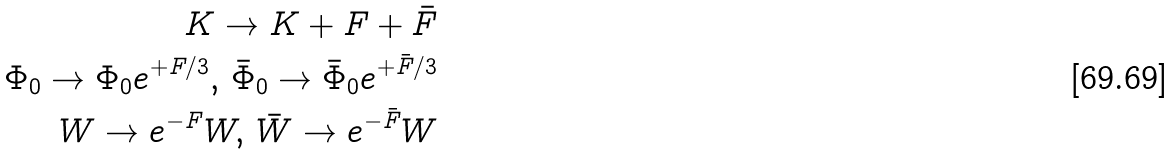Convert formula to latex. <formula><loc_0><loc_0><loc_500><loc_500>K \rightarrow K + F + \bar { F } \\ \Phi _ { 0 } \rightarrow \Phi _ { 0 } e ^ { + F / 3 } , \, \bar { \Phi } _ { 0 } \rightarrow \bar { \Phi } _ { 0 } e ^ { + \bar { F } / 3 } \\ W \rightarrow e ^ { - F } W , \, \bar { W } \rightarrow e ^ { - \bar { F } } W</formula> 